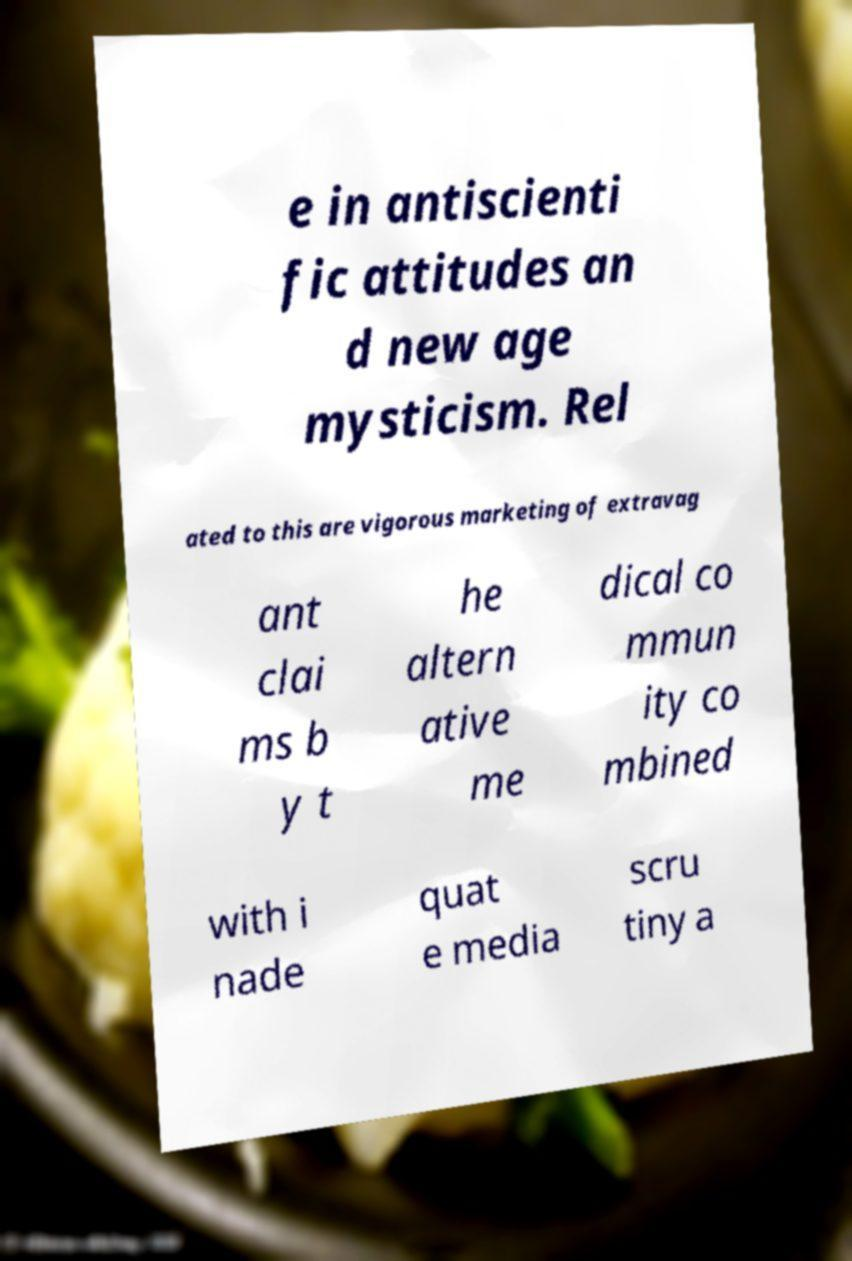I need the written content from this picture converted into text. Can you do that? e in antiscienti fic attitudes an d new age mysticism. Rel ated to this are vigorous marketing of extravag ant clai ms b y t he altern ative me dical co mmun ity co mbined with i nade quat e media scru tiny a 